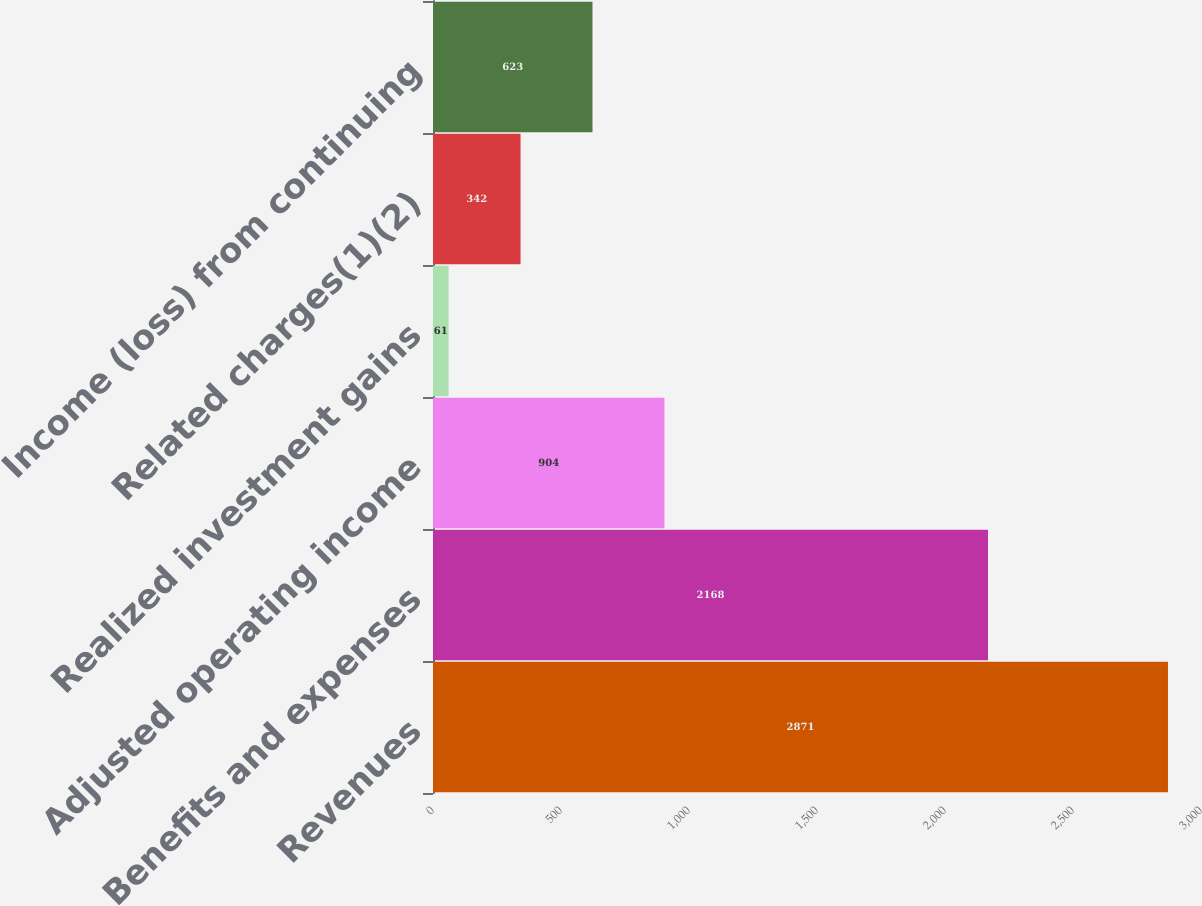<chart> <loc_0><loc_0><loc_500><loc_500><bar_chart><fcel>Revenues<fcel>Benefits and expenses<fcel>Adjusted operating income<fcel>Realized investment gains<fcel>Related charges(1)(2)<fcel>Income (loss) from continuing<nl><fcel>2871<fcel>2168<fcel>904<fcel>61<fcel>342<fcel>623<nl></chart> 